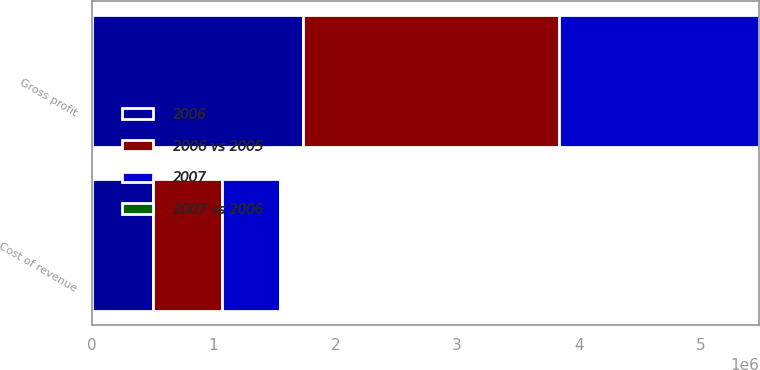<chart> <loc_0><loc_0><loc_500><loc_500><stacked_bar_chart><ecel><fcel>Cost of revenue<fcel>Gross profit<nl><fcel>2006 vs 2005<fcel>562401<fcel>2.10293e+06<nl><fcel>2006<fcel>502638<fcel>1.73495e+06<nl><fcel>2007<fcel>480219<fcel>1.63924e+06<nl><fcel>2007 vs 2006<fcel>12<fcel>21<nl></chart> 